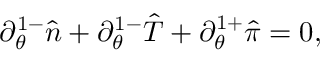Convert formula to latex. <formula><loc_0><loc_0><loc_500><loc_500>\partial _ { \theta } ^ { 1 - } \hat { n } + \partial _ { \theta } ^ { 1 - } \hat { T } + \partial _ { \theta } ^ { 1 + } \hat { \pi } = 0 ,</formula> 